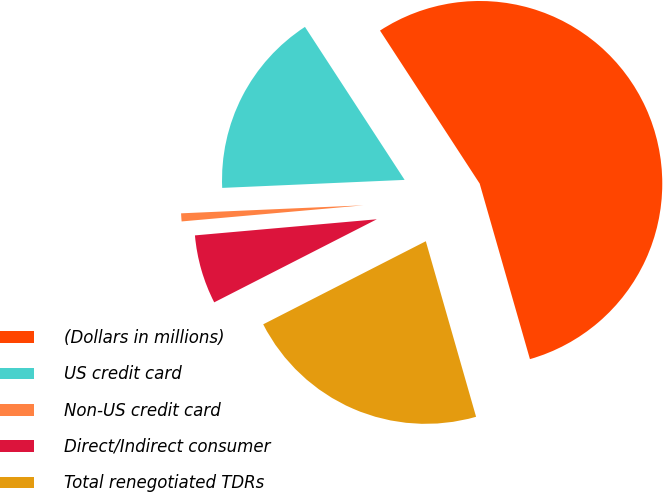<chart> <loc_0><loc_0><loc_500><loc_500><pie_chart><fcel>(Dollars in millions)<fcel>US credit card<fcel>Non-US credit card<fcel>Direct/Indirect consumer<fcel>Total renegotiated TDRs<nl><fcel>54.75%<fcel>16.51%<fcel>0.71%<fcel>6.11%<fcel>21.92%<nl></chart> 